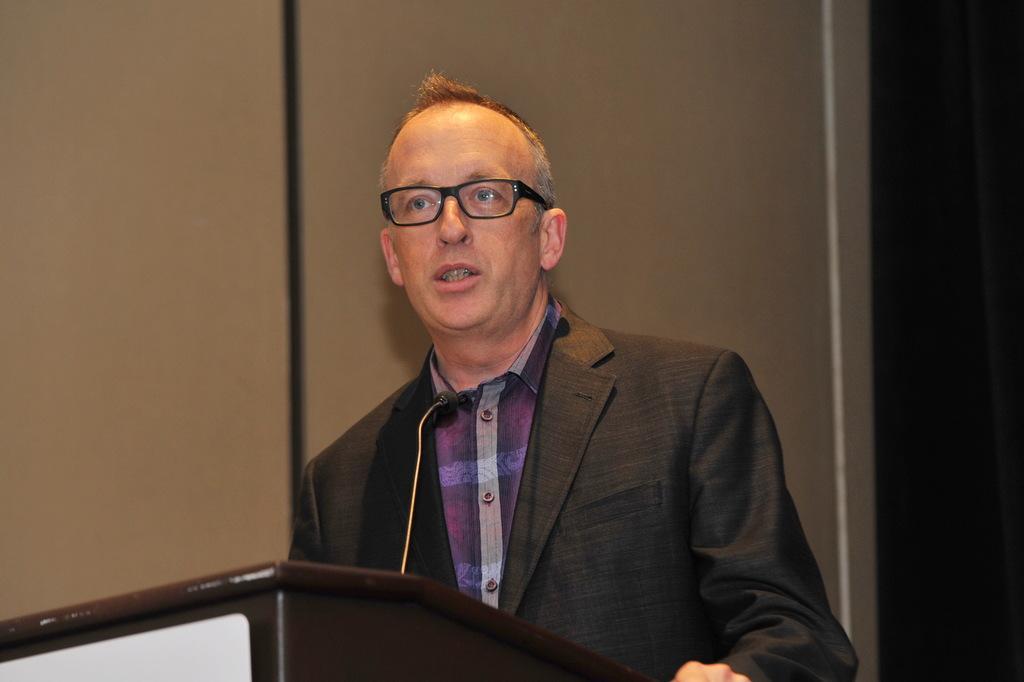In one or two sentences, can you explain what this image depicts? In this picture we can see a person, in front of him we can see a podium, mic and we can see a wall in the background. 